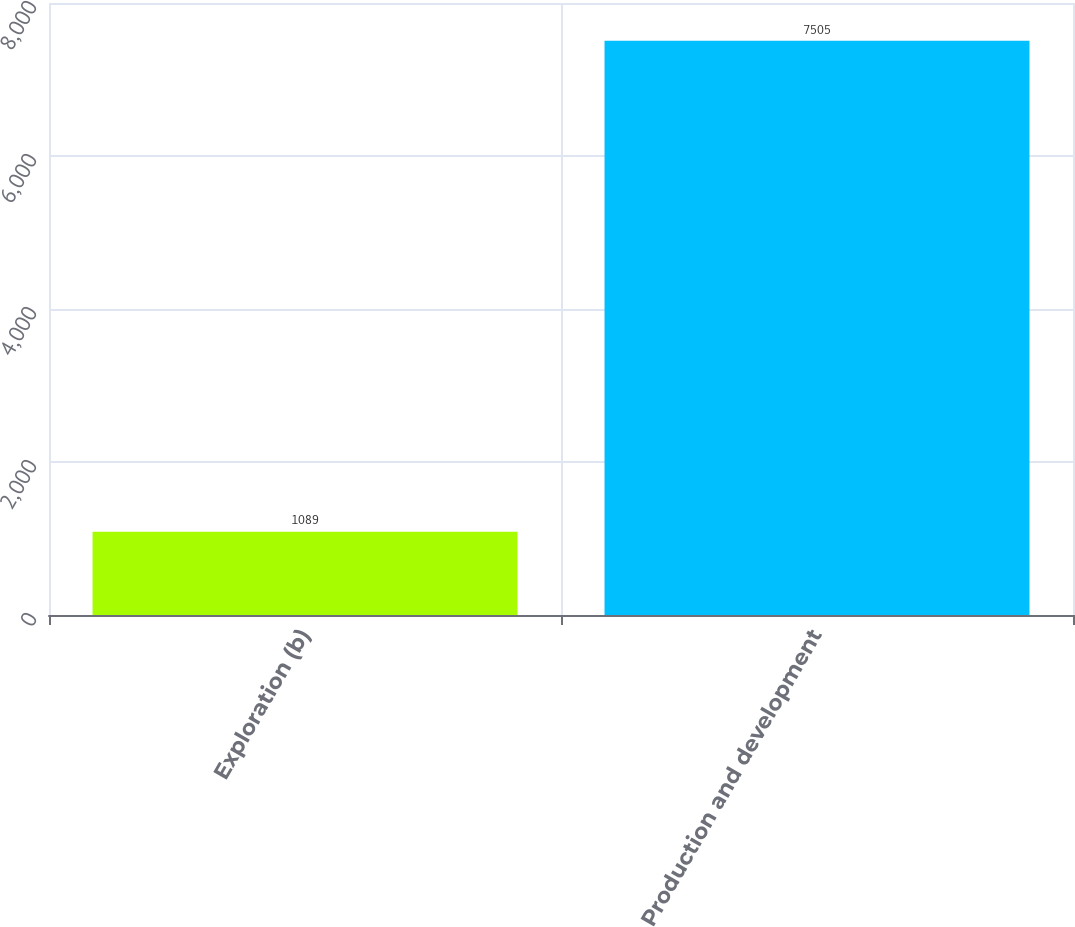Convert chart. <chart><loc_0><loc_0><loc_500><loc_500><bar_chart><fcel>Exploration (b)<fcel>Production and development<nl><fcel>1089<fcel>7505<nl></chart> 